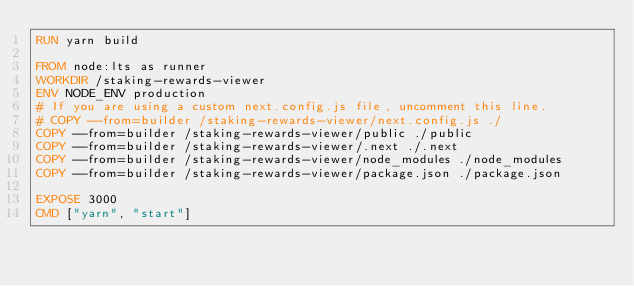Convert code to text. <code><loc_0><loc_0><loc_500><loc_500><_Dockerfile_>RUN yarn build

FROM node:lts as runner
WORKDIR /staking-rewards-viewer
ENV NODE_ENV production
# If you are using a custom next.config.js file, uncomment this line.
# COPY --from=builder /staking-rewards-viewer/next.config.js ./
COPY --from=builder /staking-rewards-viewer/public ./public
COPY --from=builder /staking-rewards-viewer/.next ./.next
COPY --from=builder /staking-rewards-viewer/node_modules ./node_modules
COPY --from=builder /staking-rewards-viewer/package.json ./package.json

EXPOSE 3000
CMD ["yarn", "start"]</code> 